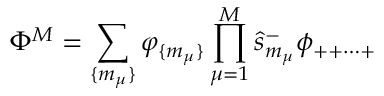<formula> <loc_0><loc_0><loc_500><loc_500>\Phi ^ { M } = \sum _ { \{ m _ { \mu } \} } \varphi _ { \{ m _ { \mu } \} } \prod _ { \mu = 1 } ^ { M } \hat { s } _ { m _ { \mu } } ^ { - } \phi _ { + + \cdots + }</formula> 